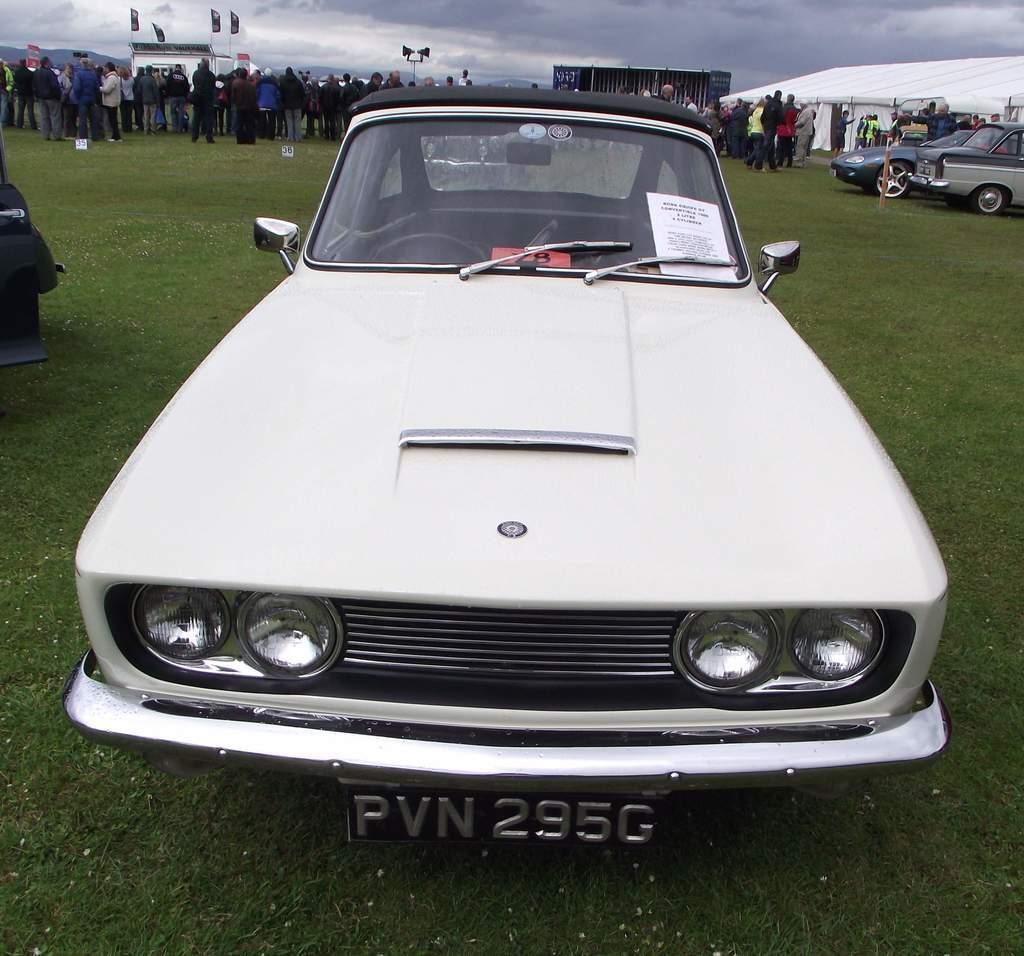Please provide a concise description of this image. In the picture I can see vehicles on the ground among them the vehicle in the front of the image is white in color. In the background I can see people, flags, the sky and some other objects on the ground. Here I can see the grass. 